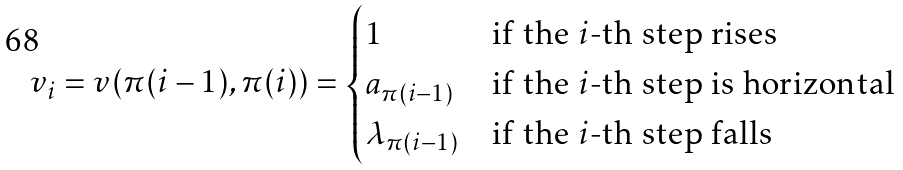Convert formula to latex. <formula><loc_0><loc_0><loc_500><loc_500>v _ { i } = v ( \pi ( i - 1 ) , \pi ( i ) ) = \begin{cases} 1 & \text {if the $i$-th step rises} \\ a _ { \pi ( i - 1 ) } & \text {if the $i$-th step is horizontal} \\ \lambda _ { \pi ( i - 1 ) } & \text {if the $i$-th step falls} \end{cases}</formula> 